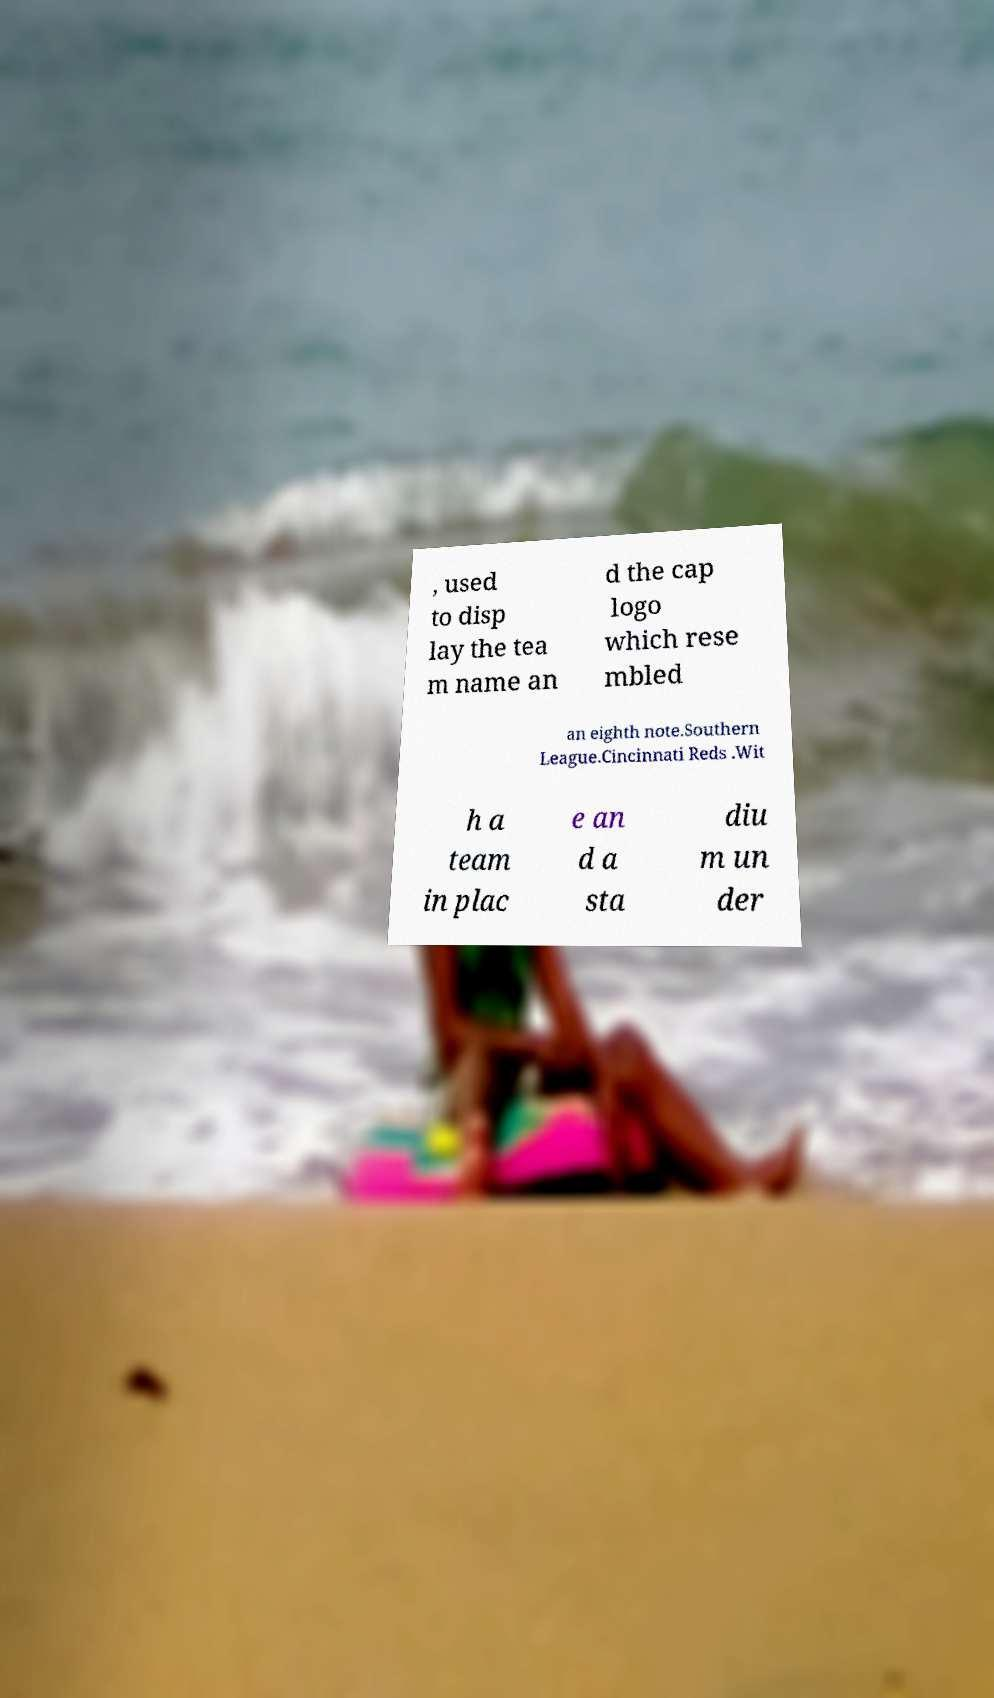Could you assist in decoding the text presented in this image and type it out clearly? , used to disp lay the tea m name an d the cap logo which rese mbled an eighth note.Southern League.Cincinnati Reds .Wit h a team in plac e an d a sta diu m un der 